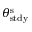Convert formula to latex. <formula><loc_0><loc_0><loc_500><loc_500>\theta _ { s t d y } ^ { s }</formula> 